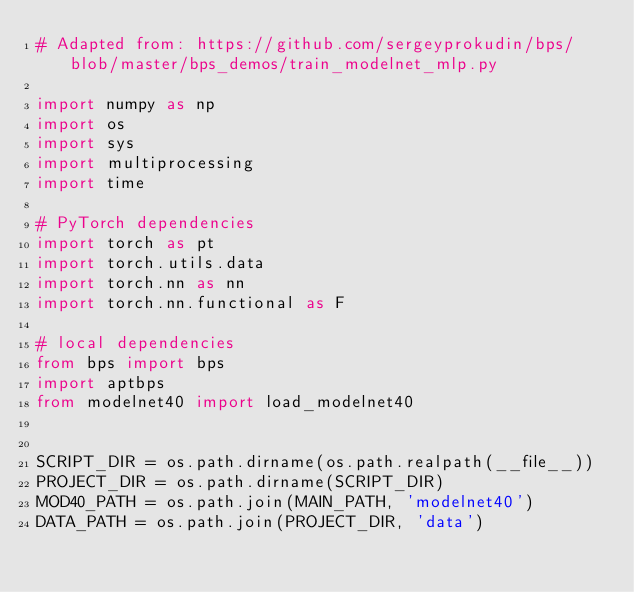<code> <loc_0><loc_0><loc_500><loc_500><_Python_># Adapted from: https://github.com/sergeyprokudin/bps/blob/master/bps_demos/train_modelnet_mlp.py

import numpy as np
import os
import sys
import multiprocessing
import time

# PyTorch dependencies
import torch as pt
import torch.utils.data
import torch.nn as nn
import torch.nn.functional as F

# local dependencies
from bps import bps
import aptbps
from modelnet40 import load_modelnet40


SCRIPT_DIR = os.path.dirname(os.path.realpath(__file__))
PROJECT_DIR = os.path.dirname(SCRIPT_DIR)
MOD40_PATH = os.path.join(MAIN_PATH, 'modelnet40')
DATA_PATH = os.path.join(PROJECT_DIR, 'data')</code> 